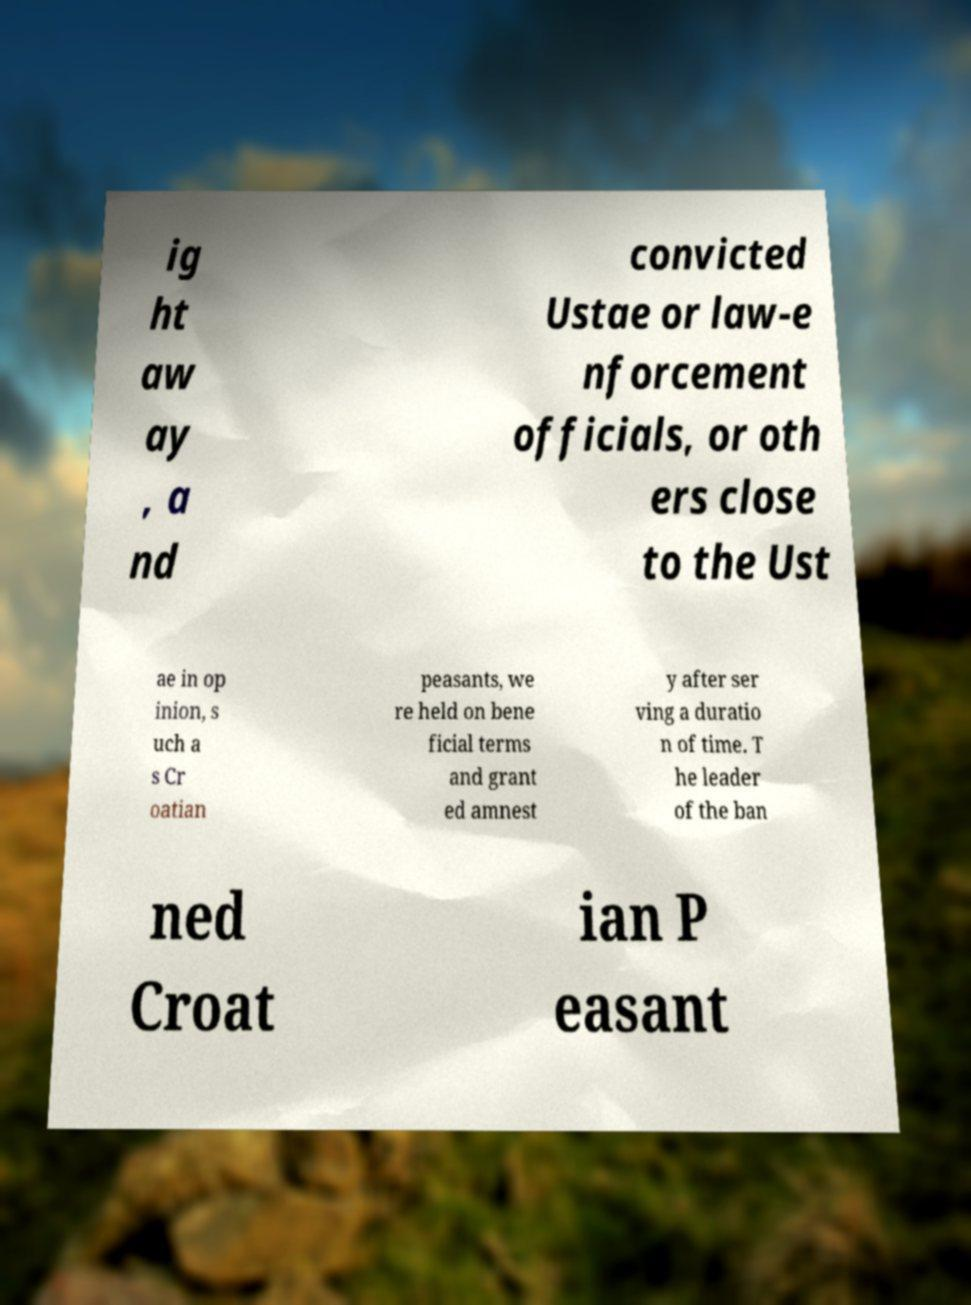There's text embedded in this image that I need extracted. Can you transcribe it verbatim? ig ht aw ay , a nd convicted Ustae or law-e nforcement officials, or oth ers close to the Ust ae in op inion, s uch a s Cr oatian peasants, we re held on bene ficial terms and grant ed amnest y after ser ving a duratio n of time. T he leader of the ban ned Croat ian P easant 